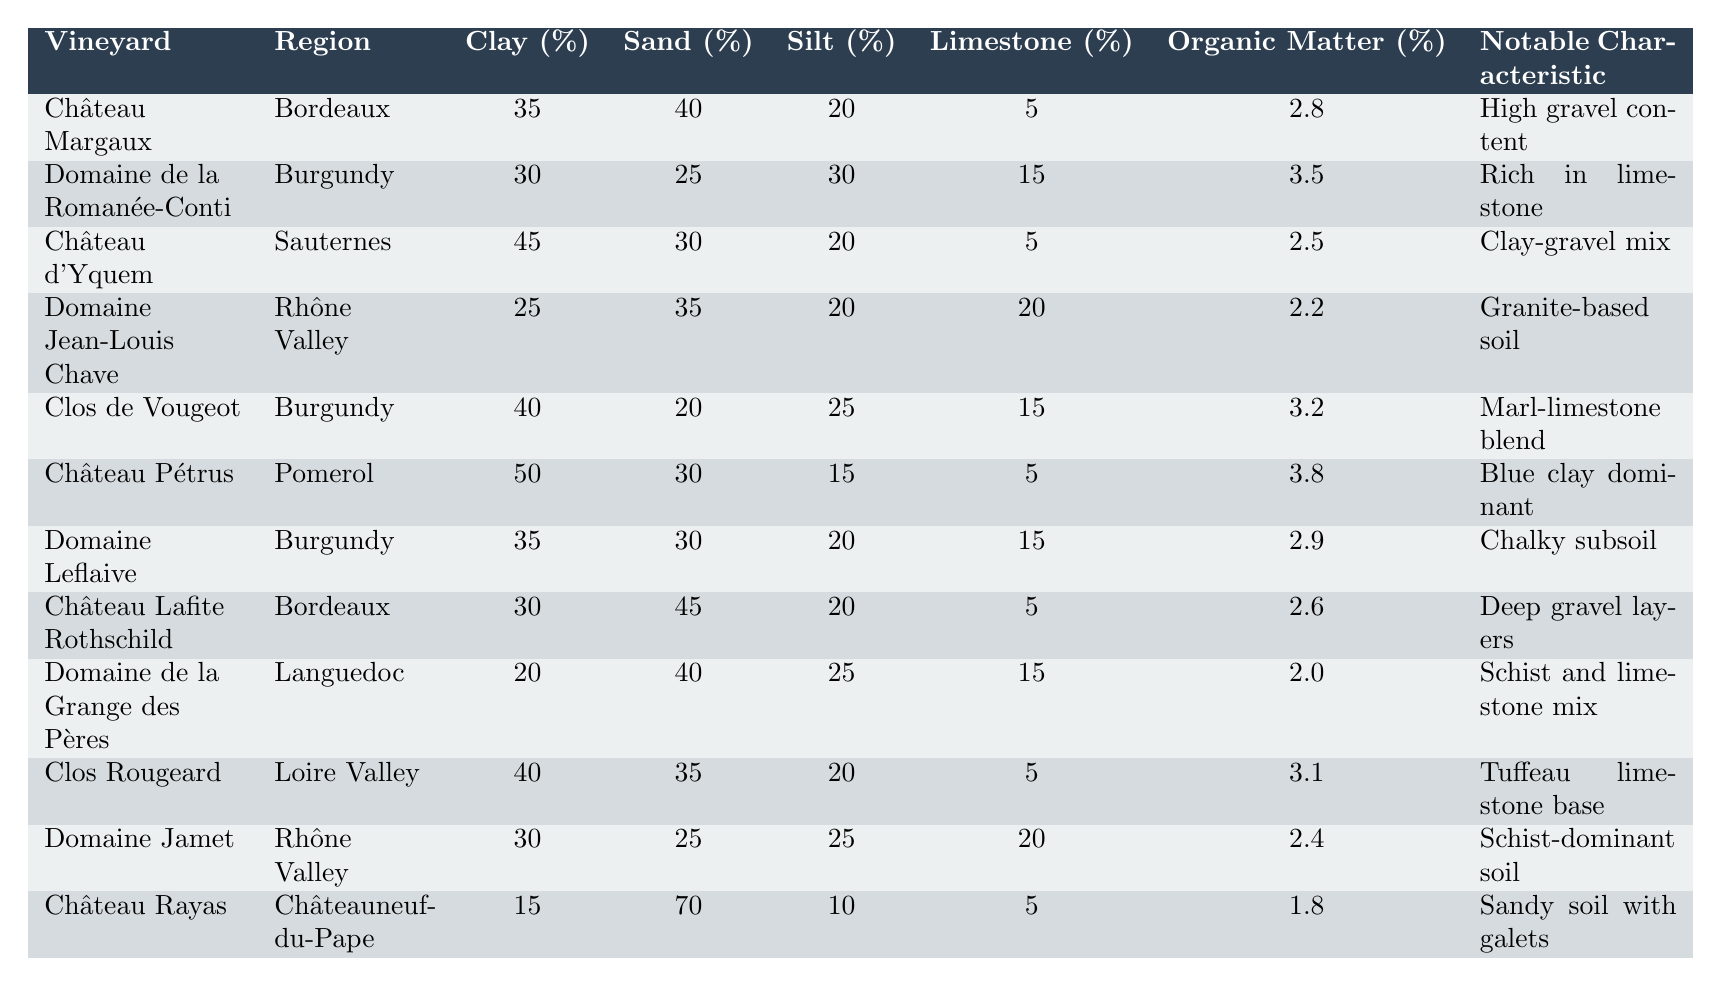What is the pH level of Château Margaux? The pH level for Château Margaux is listed in the table under the respective column. It shows 6.2.
Answer: 6.2 Which vineyard has the highest percentage of clay? By examining the Clay (%) column, Château Pétrus has the highest percentage at 50%.
Answer: Château Pétrus Calculate the average limestone percentage across all vineyards. To find the average, sum the limestone percentages (5 + 15 + 5 + 20 + 15 + 5 + 15 + 5 + 15 + 5 + 20 + 5) = 160. There are 12 vineyards, so 160/12 = 13.33.
Answer: 13.33 Is Domaine de la Romanée-Conti rich in limestone? The notable characteristic is listed as "Rich in limestone", affirming that it is indeed rich in limestone.
Answer: Yes Which vineyard has the lowest organic matter percentage? The Organic Matter (%) column shows that Domaine de la Grange des Pères has the lowest at 2.0%.
Answer: Domaine de la Grange des Pères Which region has the highest average sand percentage? Calculate the average sand percentage for each region: Bordeaux (42.5), Burgundy (25), Sauternes (30), Rhône Valley (30), Pomerol (30), Languedoc (40), Loire Valley (35), Châteauneuf-du-Pape (70). The highest average is for Châteauneuf-du-Pape with 70%.
Answer: Châteauneuf-du-Pape Does Clos Rougeard have more clay than Château d'Yquem? Clos Rougeard has 40% clay, while Château d'Yquem has 45%. Since 40 is less than 45, Clos Rougeard does not have more clay.
Answer: No Which vineyard has a notable characteristic of "Tuffeau limestone base"? The notable characteristic "Tuffeau limestone base" is attributed to Clos Rougeard according to the table.
Answer: Clos Rougeard How many vineyards have a sand percentage greater than 30%? Looking through the Sand (%) column, the vineyards with percentages greater than 30% are Château Margaux, Château Lafite Rothschild, Château Rayas, and Domaine de la Grange des Pères, totaling 4 vineyards.
Answer: 4 Calculate the difference in pH between the vineyard with the highest pH and the one with the lowest. The highest pH is for Domaine de la Grange des Pères (7.6), and the lowest is for Château Rayas (7.0). The difference is 7.6 - 7.0 = 0.6.
Answer: 0.6 